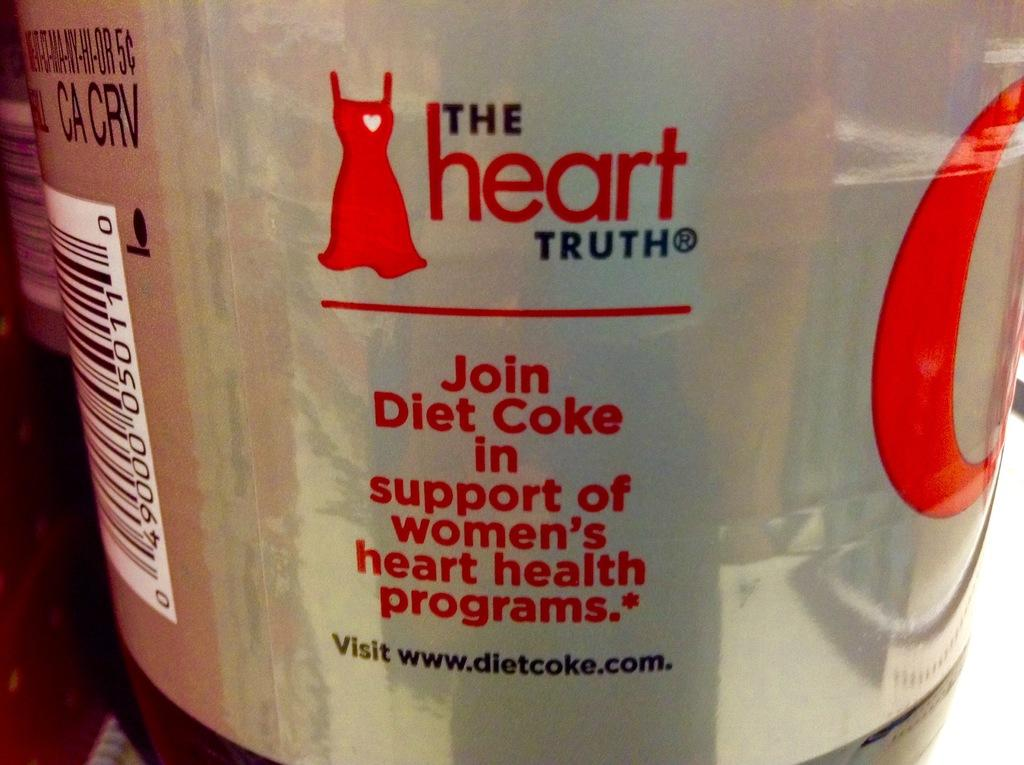<image>
Offer a succinct explanation of the picture presented. A can of Diet Coke asking to join programs supporting women's health. 